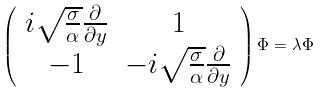Convert formula to latex. <formula><loc_0><loc_0><loc_500><loc_500>\left ( \begin{array} { c c } i \sqrt { \frac { \sigma } { \alpha } } \frac { \partial } { \partial y } & 1 \\ - 1 & - i \sqrt { \frac { \sigma } { \alpha } } \frac { \partial } { \partial y } \end{array} \right ) \Phi = \lambda \Phi</formula> 